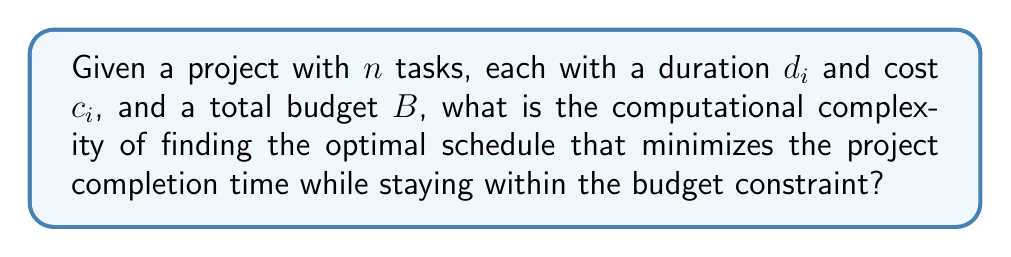Could you help me with this problem? To analyze the computational complexity of this problem, we need to consider the following steps:

1. Problem formulation: This problem is a variation of the Resource-Constrained Project Scheduling Problem (RCPSP), which is known to be NP-hard.

2. Decision variables: For each task $i$, we need to determine its start time $s_i$. This gives us $n$ decision variables.

3. Objective function: Minimize the project completion time, which is $\max_{i=1}^n (s_i + d_i)$.

4. Constraints:
   a. Precedence constraints: Some tasks may need to be completed before others can start.
   b. Budget constraint: $\sum_{i=1}^n c_i \leq B$

5. Solution space: The number of possible schedules grows exponentially with the number of tasks. In the worst case, we might need to examine all possible permutations of tasks, which is $O(n!)$.

6. Reduction: This problem can be reduced from the Knapsack problem, which is NP-complete. We can show this by considering each task as an item with weight (cost) and value (negative duration), and the budget as the knapsack capacity.

7. Approximation: While polynomial-time approximation algorithms exist for some variations of this problem, finding the exact optimal solution remains NP-hard.

Given these considerations, we can conclude that the problem of finding the optimal schedule under budget constraints is NP-hard. This means that there is no known polynomial-time algorithm to solve it exactly for all instances.

In practice, for a project manager, this implies that for large projects with many tasks, finding the truly optimal schedule may be computationally infeasible. Heuristic methods or approximation algorithms are often used instead to find near-optimal solutions in reasonable time.
Answer: The computational complexity of finding the optimal schedule that minimizes the project completion time while staying within the budget constraint is NP-hard. 